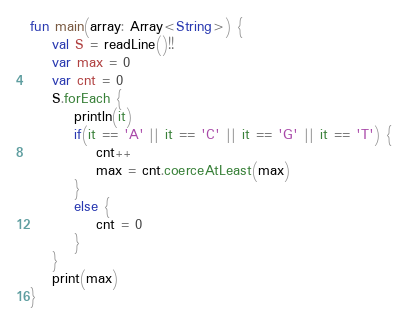Convert code to text. <code><loc_0><loc_0><loc_500><loc_500><_Kotlin_>fun main(array: Array<String>) {
    val S = readLine()!!
    var max = 0
    var cnt = 0
    S.forEach {
        println(it)
        if(it == 'A' || it == 'C' || it == 'G' || it == 'T') {
            cnt++
            max = cnt.coerceAtLeast(max)
        }
        else {
            cnt = 0
        }
    }
    print(max)
}</code> 